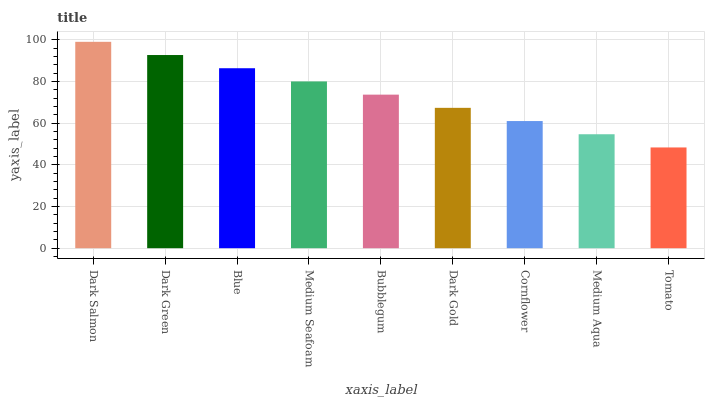Is Tomato the minimum?
Answer yes or no. Yes. Is Dark Salmon the maximum?
Answer yes or no. Yes. Is Dark Green the minimum?
Answer yes or no. No. Is Dark Green the maximum?
Answer yes or no. No. Is Dark Salmon greater than Dark Green?
Answer yes or no. Yes. Is Dark Green less than Dark Salmon?
Answer yes or no. Yes. Is Dark Green greater than Dark Salmon?
Answer yes or no. No. Is Dark Salmon less than Dark Green?
Answer yes or no. No. Is Bubblegum the high median?
Answer yes or no. Yes. Is Bubblegum the low median?
Answer yes or no. Yes. Is Medium Seafoam the high median?
Answer yes or no. No. Is Dark Salmon the low median?
Answer yes or no. No. 